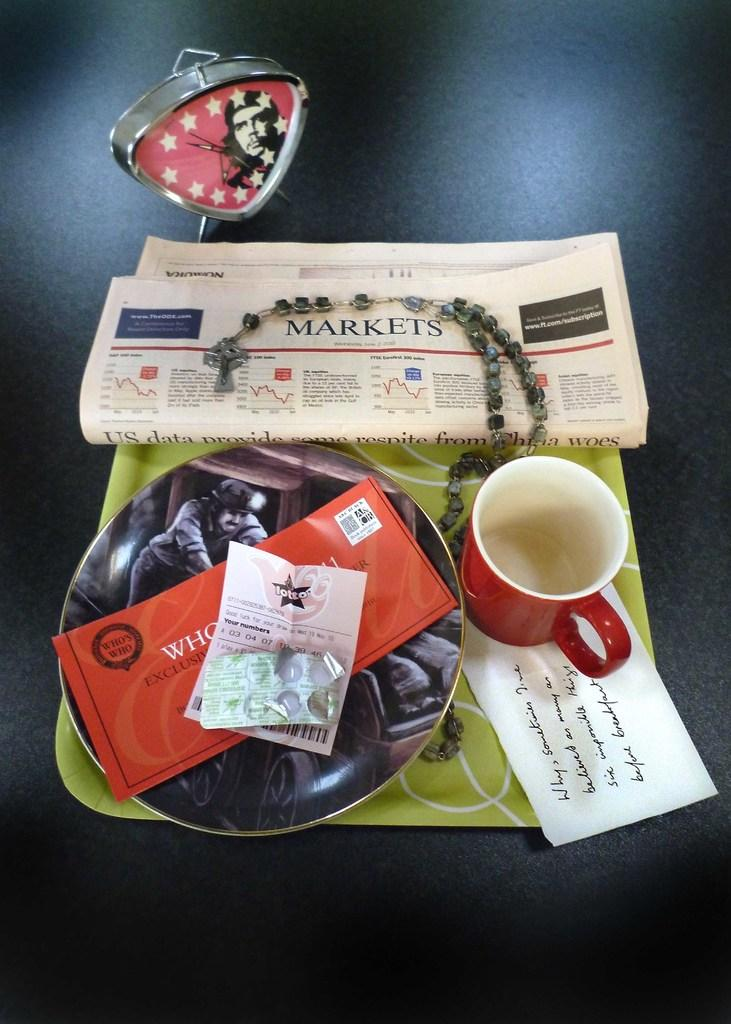Provide a one-sentence caption for the provided image. A tray with dishes and a newspaper showing the Markets page on it. 